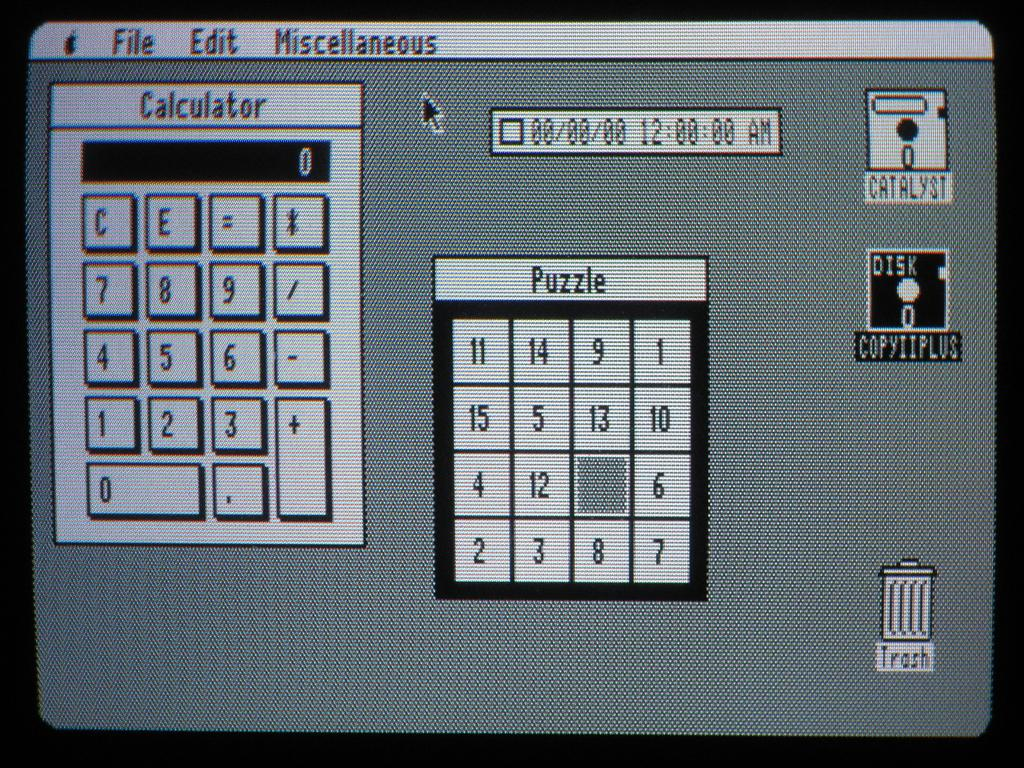<image>
Create a compact narrative representing the image presented. A computer screen with a calculator and puzzle displayed with the desktop. 